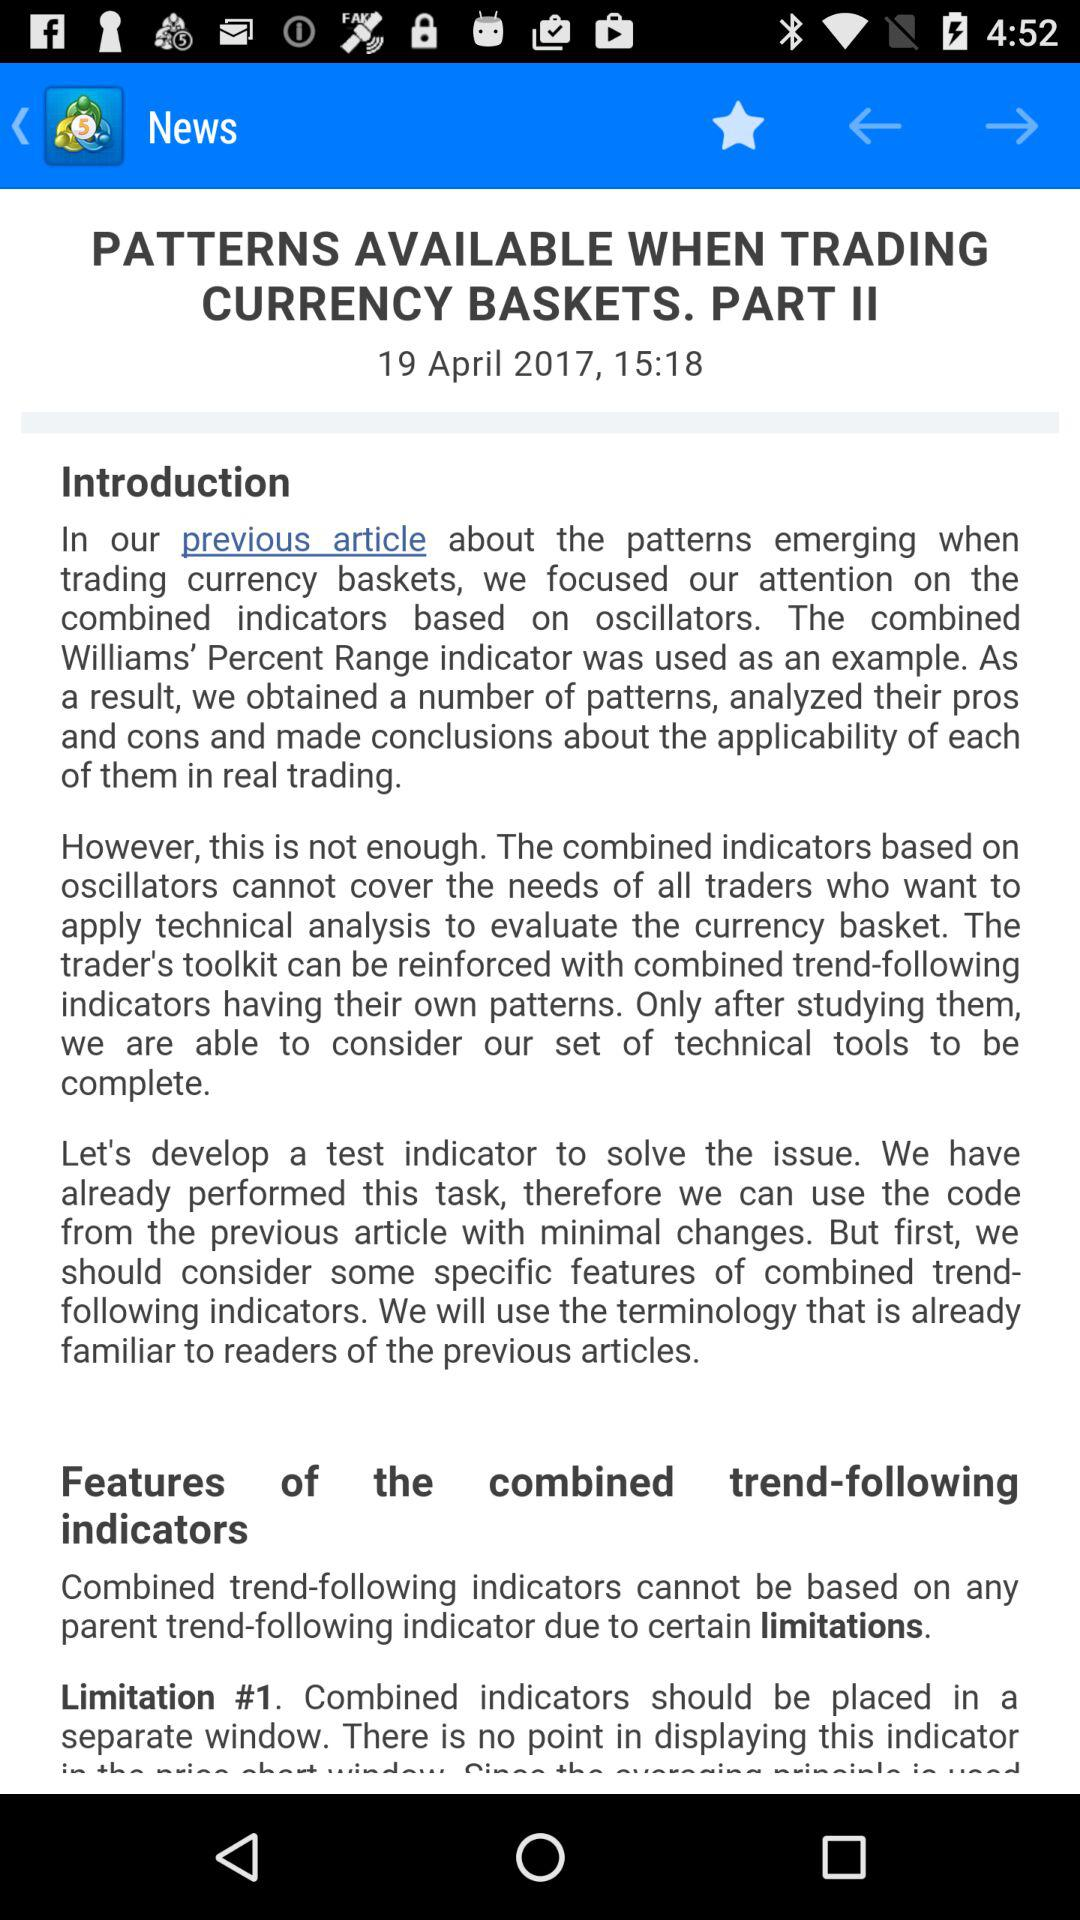Who wrote "PATTERNS AVAILABLE WHEN TRADING CURRENCY BASKETS. PART II"?
When the provided information is insufficient, respond with <no answer>. <no answer> 